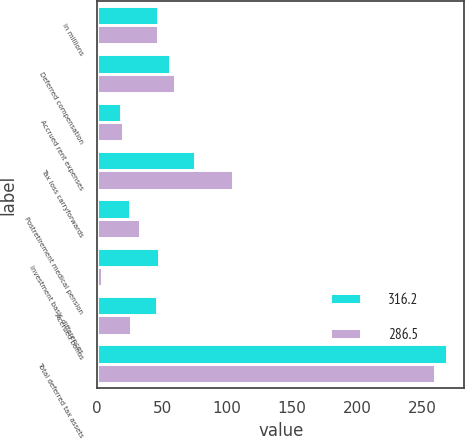<chart> <loc_0><loc_0><loc_500><loc_500><stacked_bar_chart><ecel><fcel>in millions<fcel>Deferred compensation<fcel>Accrued rent expenses<fcel>Tax loss carryforwards<fcel>Postretirement medical pension<fcel>Investment basis differences<fcel>Accrued bonus<fcel>Total deferred tax assets<nl><fcel>316.2<fcel>47.05<fcel>56.2<fcel>18.3<fcel>75<fcel>25.5<fcel>47.8<fcel>46.3<fcel>269.1<nl><fcel>286.5<fcel>47.05<fcel>59.6<fcel>20<fcel>104.8<fcel>32.6<fcel>3.9<fcel>25.9<fcel>259.9<nl></chart> 